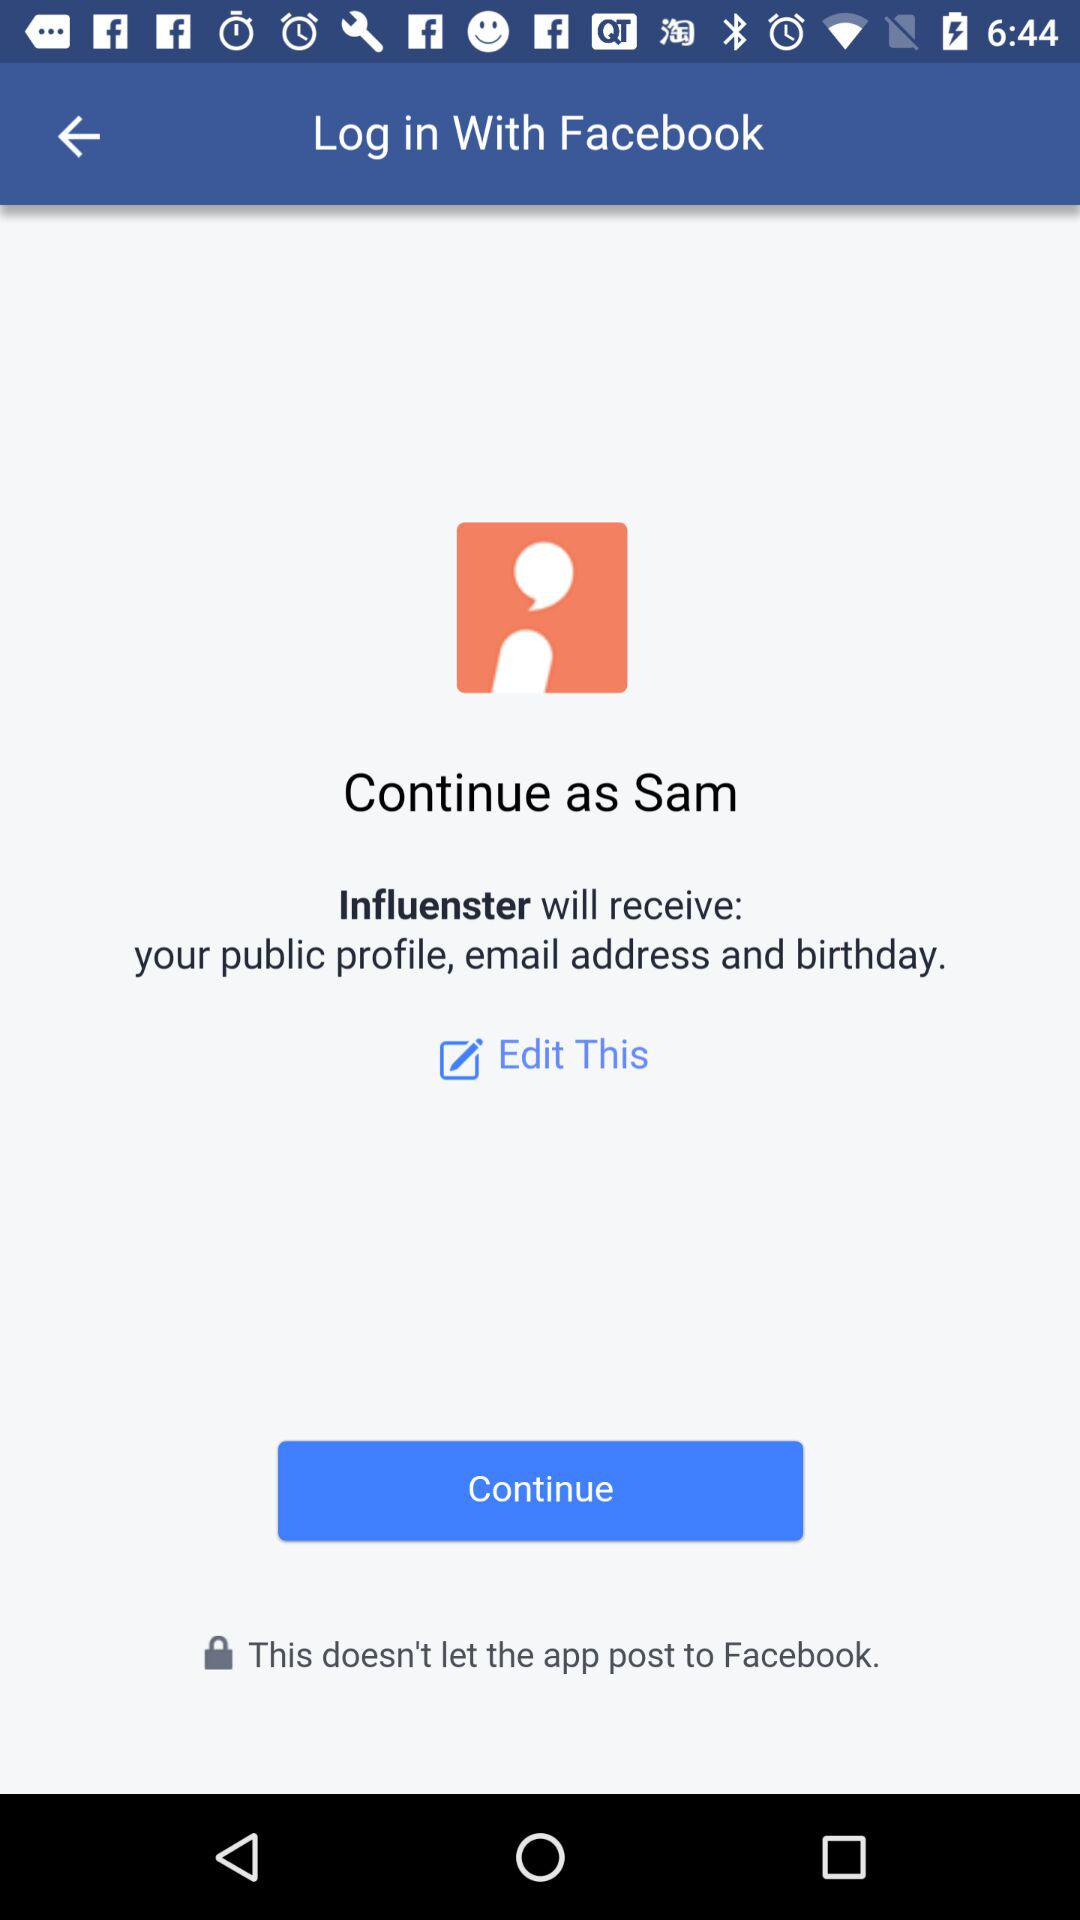What application is asking for permission? The application asking for permission is "Influenster". 